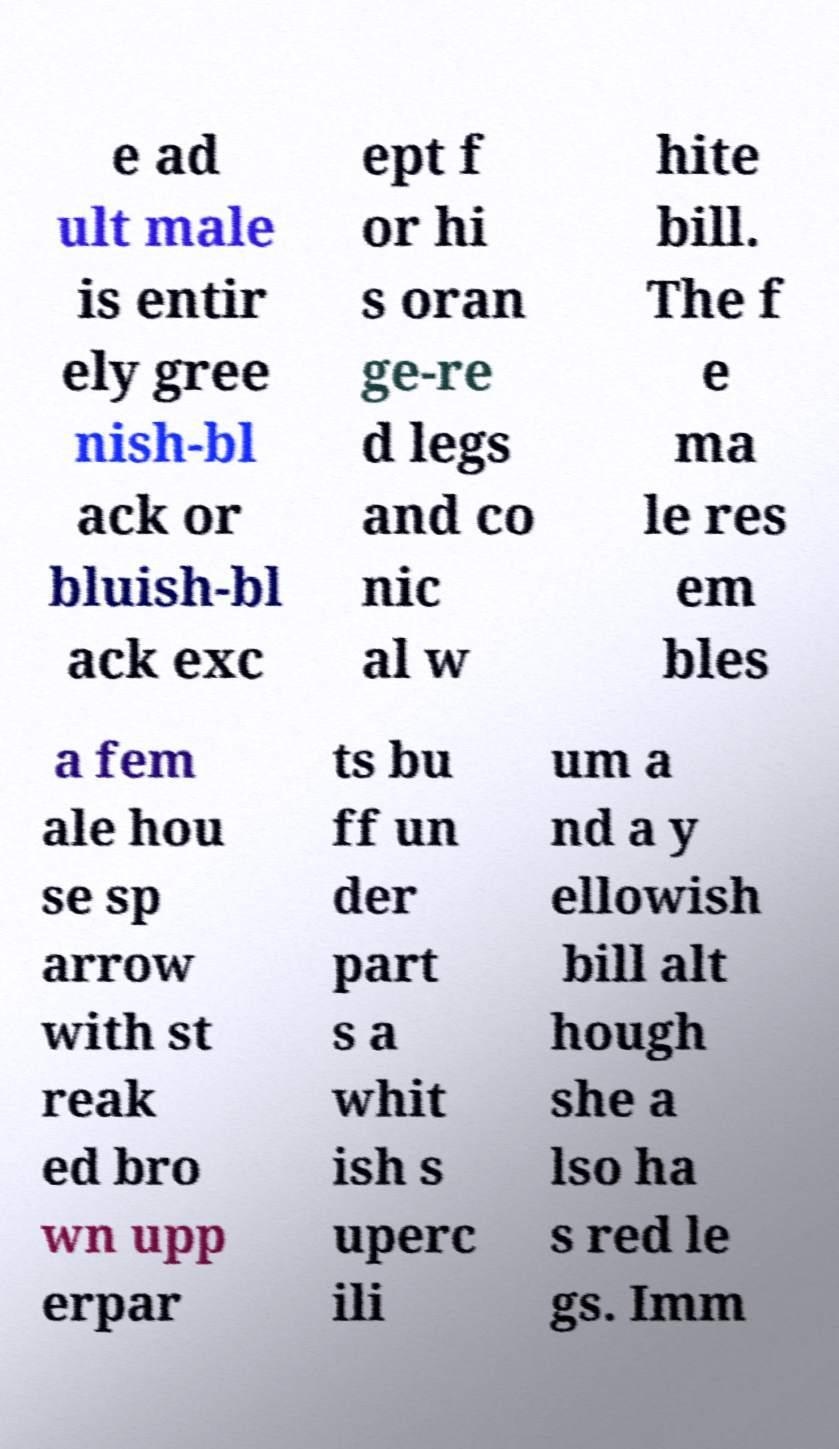I need the written content from this picture converted into text. Can you do that? e ad ult male is entir ely gree nish-bl ack or bluish-bl ack exc ept f or hi s oran ge-re d legs and co nic al w hite bill. The f e ma le res em bles a fem ale hou se sp arrow with st reak ed bro wn upp erpar ts bu ff un der part s a whit ish s uperc ili um a nd a y ellowish bill alt hough she a lso ha s red le gs. Imm 